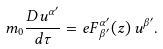<formula> <loc_0><loc_0><loc_500><loc_500>m _ { 0 } \frac { D u ^ { \alpha ^ { \prime } } } { d \tau } = e F ^ { \alpha ^ { \prime } } _ { \, \beta ^ { \prime } } ( z ) \, u ^ { \beta ^ { \prime } } .</formula> 